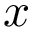Convert formula to latex. <formula><loc_0><loc_0><loc_500><loc_500>x</formula> 